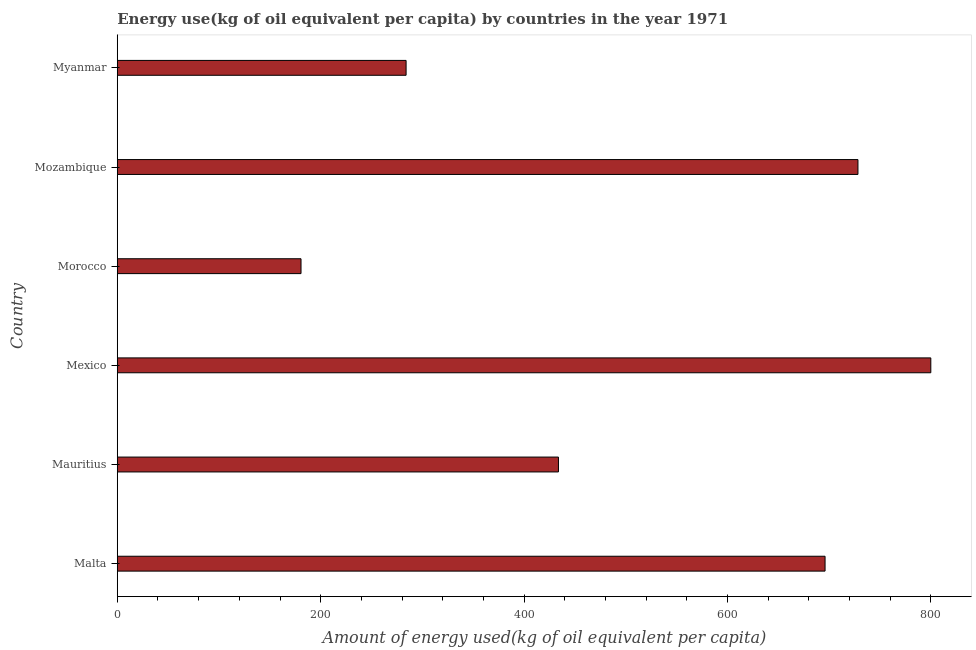Does the graph contain any zero values?
Give a very brief answer. No. What is the title of the graph?
Provide a succinct answer. Energy use(kg of oil equivalent per capita) by countries in the year 1971. What is the label or title of the X-axis?
Provide a succinct answer. Amount of energy used(kg of oil equivalent per capita). What is the amount of energy used in Mauritius?
Provide a short and direct response. 433.8. Across all countries, what is the maximum amount of energy used?
Ensure brevity in your answer.  799.94. Across all countries, what is the minimum amount of energy used?
Provide a succinct answer. 180.67. In which country was the amount of energy used maximum?
Offer a very short reply. Mexico. In which country was the amount of energy used minimum?
Provide a succinct answer. Morocco. What is the sum of the amount of energy used?
Give a very brief answer. 3122.65. What is the difference between the amount of energy used in Mexico and Mozambique?
Your response must be concise. 71.64. What is the average amount of energy used per country?
Your answer should be very brief. 520.44. What is the median amount of energy used?
Make the answer very short. 564.88. What is the ratio of the amount of energy used in Malta to that in Mauritius?
Your answer should be very brief. 1.6. Is the amount of energy used in Mauritius less than that in Morocco?
Ensure brevity in your answer.  No. What is the difference between the highest and the second highest amount of energy used?
Your response must be concise. 71.64. Is the sum of the amount of energy used in Mauritius and Morocco greater than the maximum amount of energy used across all countries?
Provide a succinct answer. No. What is the difference between the highest and the lowest amount of energy used?
Offer a terse response. 619.27. How many bars are there?
Give a very brief answer. 6. Are all the bars in the graph horizontal?
Make the answer very short. Yes. How many countries are there in the graph?
Keep it short and to the point. 6. Are the values on the major ticks of X-axis written in scientific E-notation?
Give a very brief answer. No. What is the Amount of energy used(kg of oil equivalent per capita) of Malta?
Provide a succinct answer. 695.96. What is the Amount of energy used(kg of oil equivalent per capita) in Mauritius?
Give a very brief answer. 433.8. What is the Amount of energy used(kg of oil equivalent per capita) in Mexico?
Give a very brief answer. 799.94. What is the Amount of energy used(kg of oil equivalent per capita) of Morocco?
Offer a very short reply. 180.67. What is the Amount of energy used(kg of oil equivalent per capita) of Mozambique?
Your answer should be compact. 728.3. What is the Amount of energy used(kg of oil equivalent per capita) in Myanmar?
Provide a succinct answer. 283.98. What is the difference between the Amount of energy used(kg of oil equivalent per capita) in Malta and Mauritius?
Your answer should be compact. 262.16. What is the difference between the Amount of energy used(kg of oil equivalent per capita) in Malta and Mexico?
Provide a short and direct response. -103.99. What is the difference between the Amount of energy used(kg of oil equivalent per capita) in Malta and Morocco?
Keep it short and to the point. 515.29. What is the difference between the Amount of energy used(kg of oil equivalent per capita) in Malta and Mozambique?
Your answer should be compact. -32.34. What is the difference between the Amount of energy used(kg of oil equivalent per capita) in Malta and Myanmar?
Make the answer very short. 411.97. What is the difference between the Amount of energy used(kg of oil equivalent per capita) in Mauritius and Mexico?
Offer a very short reply. -366.15. What is the difference between the Amount of energy used(kg of oil equivalent per capita) in Mauritius and Morocco?
Offer a terse response. 253.13. What is the difference between the Amount of energy used(kg of oil equivalent per capita) in Mauritius and Mozambique?
Give a very brief answer. -294.5. What is the difference between the Amount of energy used(kg of oil equivalent per capita) in Mauritius and Myanmar?
Ensure brevity in your answer.  149.81. What is the difference between the Amount of energy used(kg of oil equivalent per capita) in Mexico and Morocco?
Your answer should be compact. 619.27. What is the difference between the Amount of energy used(kg of oil equivalent per capita) in Mexico and Mozambique?
Offer a terse response. 71.65. What is the difference between the Amount of energy used(kg of oil equivalent per capita) in Mexico and Myanmar?
Provide a succinct answer. 515.96. What is the difference between the Amount of energy used(kg of oil equivalent per capita) in Morocco and Mozambique?
Offer a very short reply. -547.63. What is the difference between the Amount of energy used(kg of oil equivalent per capita) in Morocco and Myanmar?
Give a very brief answer. -103.31. What is the difference between the Amount of energy used(kg of oil equivalent per capita) in Mozambique and Myanmar?
Give a very brief answer. 444.32. What is the ratio of the Amount of energy used(kg of oil equivalent per capita) in Malta to that in Mauritius?
Ensure brevity in your answer.  1.6. What is the ratio of the Amount of energy used(kg of oil equivalent per capita) in Malta to that in Mexico?
Offer a very short reply. 0.87. What is the ratio of the Amount of energy used(kg of oil equivalent per capita) in Malta to that in Morocco?
Offer a very short reply. 3.85. What is the ratio of the Amount of energy used(kg of oil equivalent per capita) in Malta to that in Mozambique?
Provide a short and direct response. 0.96. What is the ratio of the Amount of energy used(kg of oil equivalent per capita) in Malta to that in Myanmar?
Your response must be concise. 2.45. What is the ratio of the Amount of energy used(kg of oil equivalent per capita) in Mauritius to that in Mexico?
Offer a very short reply. 0.54. What is the ratio of the Amount of energy used(kg of oil equivalent per capita) in Mauritius to that in Morocco?
Give a very brief answer. 2.4. What is the ratio of the Amount of energy used(kg of oil equivalent per capita) in Mauritius to that in Mozambique?
Give a very brief answer. 0.6. What is the ratio of the Amount of energy used(kg of oil equivalent per capita) in Mauritius to that in Myanmar?
Ensure brevity in your answer.  1.53. What is the ratio of the Amount of energy used(kg of oil equivalent per capita) in Mexico to that in Morocco?
Provide a succinct answer. 4.43. What is the ratio of the Amount of energy used(kg of oil equivalent per capita) in Mexico to that in Mozambique?
Give a very brief answer. 1.1. What is the ratio of the Amount of energy used(kg of oil equivalent per capita) in Mexico to that in Myanmar?
Make the answer very short. 2.82. What is the ratio of the Amount of energy used(kg of oil equivalent per capita) in Morocco to that in Mozambique?
Give a very brief answer. 0.25. What is the ratio of the Amount of energy used(kg of oil equivalent per capita) in Morocco to that in Myanmar?
Ensure brevity in your answer.  0.64. What is the ratio of the Amount of energy used(kg of oil equivalent per capita) in Mozambique to that in Myanmar?
Your answer should be very brief. 2.56. 